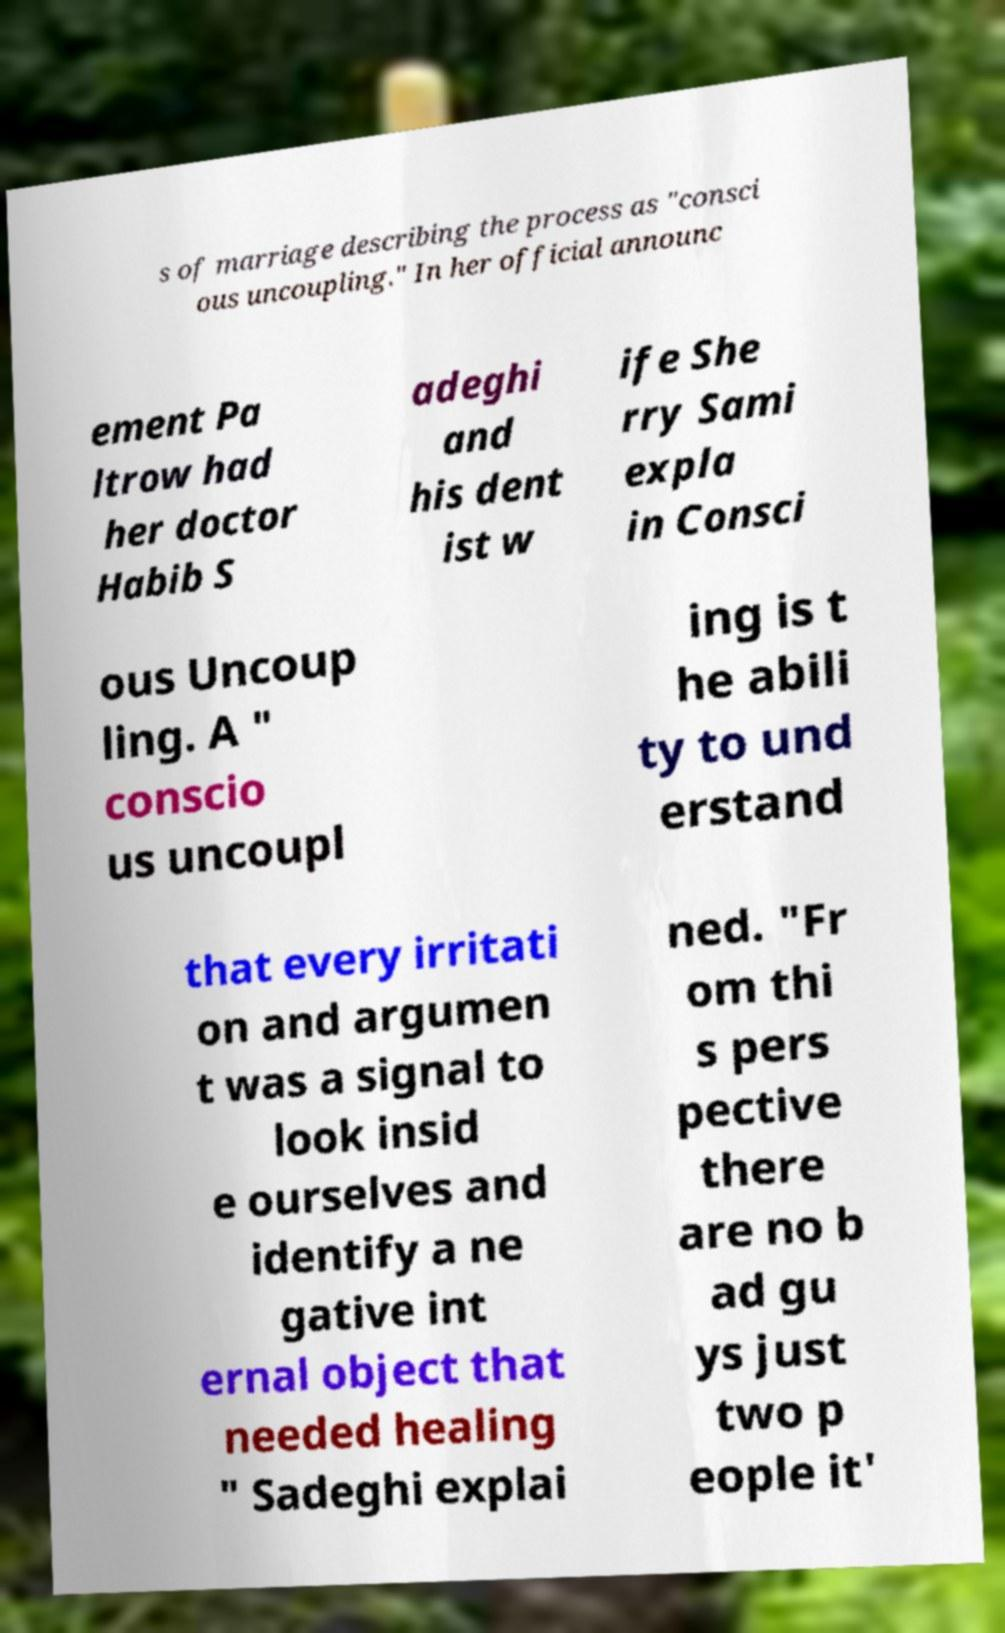I need the written content from this picture converted into text. Can you do that? s of marriage describing the process as "consci ous uncoupling." In her official announc ement Pa ltrow had her doctor Habib S adeghi and his dent ist w ife She rry Sami expla in Consci ous Uncoup ling. A " conscio us uncoupl ing is t he abili ty to und erstand that every irritati on and argumen t was a signal to look insid e ourselves and identify a ne gative int ernal object that needed healing " Sadeghi explai ned. "Fr om thi s pers pective there are no b ad gu ys just two p eople it' 